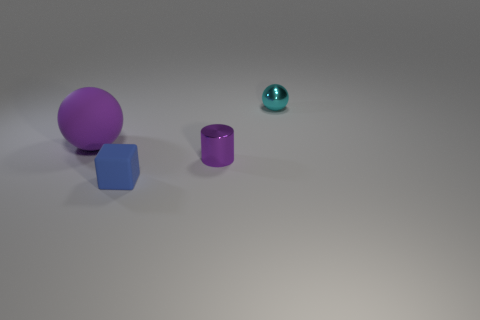Add 1 tiny cubes. How many objects exist? 5 Subtract all cubes. How many objects are left? 3 Add 3 small cyan matte things. How many small cyan matte things exist? 3 Subtract 0 cyan cylinders. How many objects are left? 4 Subtract all rubber things. Subtract all blue matte blocks. How many objects are left? 1 Add 2 tiny blue matte blocks. How many tiny blue matte blocks are left? 3 